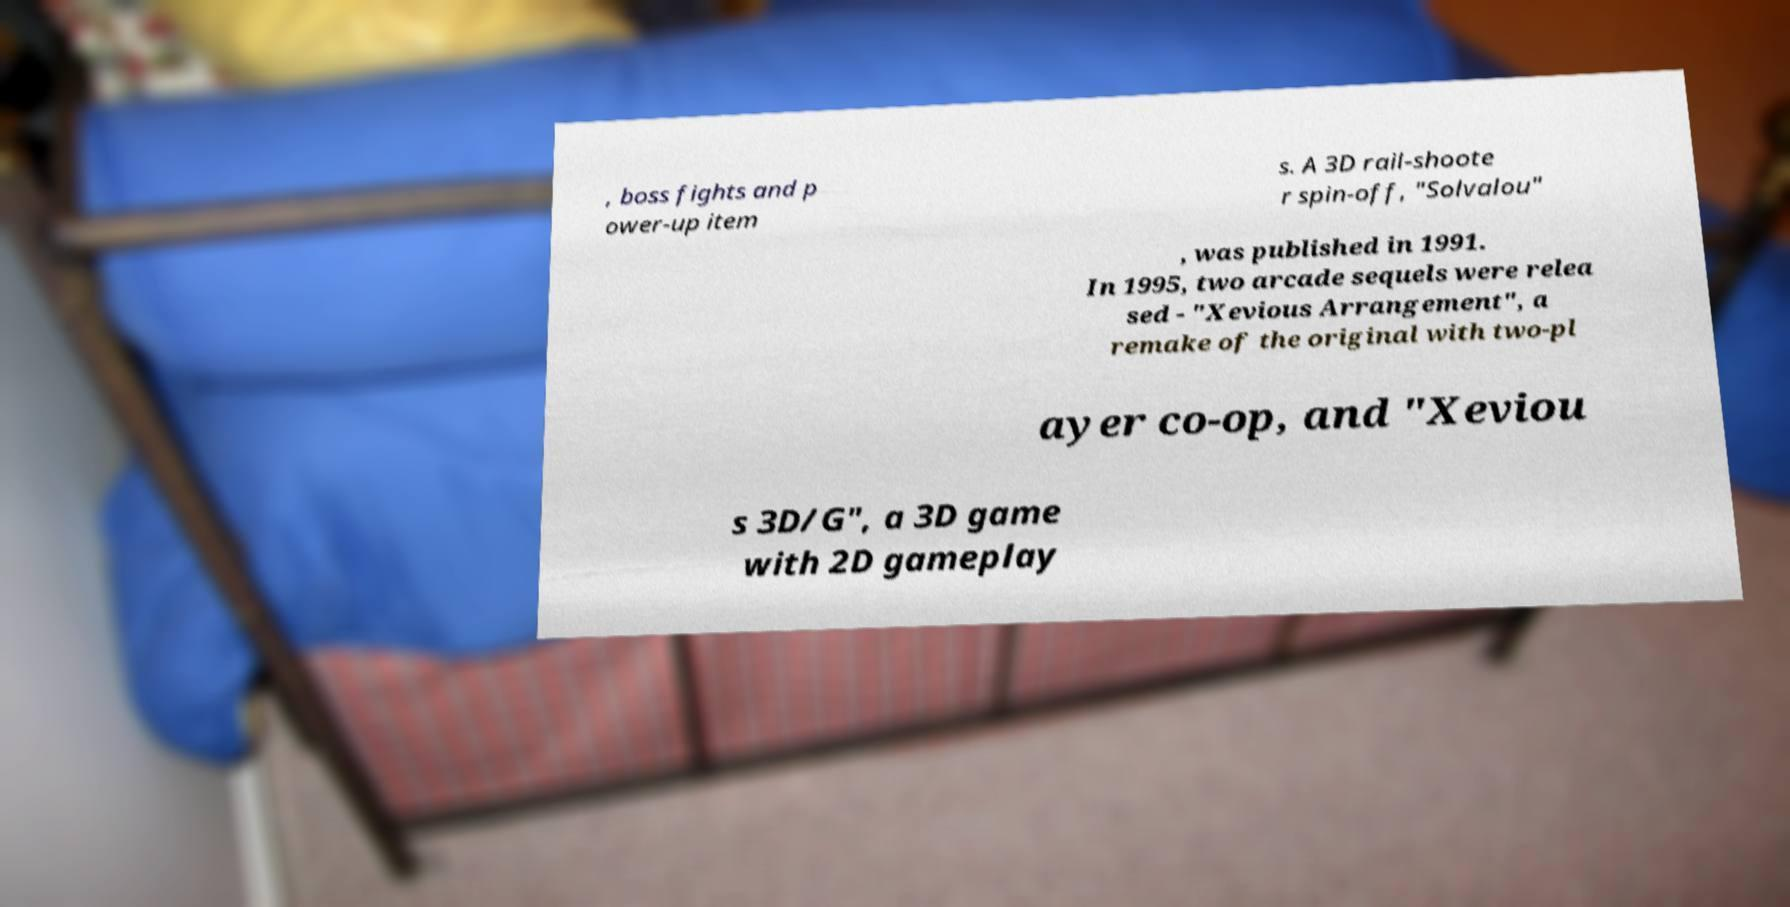Please read and relay the text visible in this image. What does it say? , boss fights and p ower-up item s. A 3D rail-shoote r spin-off, "Solvalou" , was published in 1991. In 1995, two arcade sequels were relea sed - "Xevious Arrangement", a remake of the original with two-pl ayer co-op, and "Xeviou s 3D/G", a 3D game with 2D gameplay 